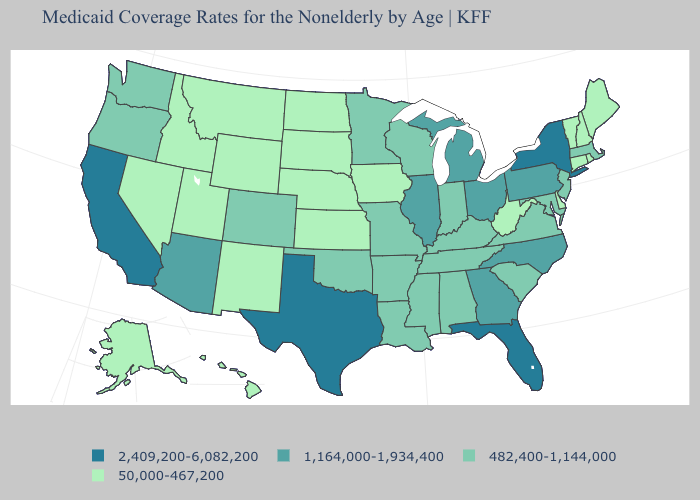Does the first symbol in the legend represent the smallest category?
Short answer required. No. Name the states that have a value in the range 2,409,200-6,082,200?
Quick response, please. California, Florida, New York, Texas. What is the highest value in the MidWest ?
Concise answer only. 1,164,000-1,934,400. Which states have the highest value in the USA?
Write a very short answer. California, Florida, New York, Texas. Which states hav the highest value in the West?
Be succinct. California. Which states have the lowest value in the MidWest?
Answer briefly. Iowa, Kansas, Nebraska, North Dakota, South Dakota. How many symbols are there in the legend?
Be succinct. 4. Name the states that have a value in the range 1,164,000-1,934,400?
Quick response, please. Arizona, Georgia, Illinois, Michigan, North Carolina, Ohio, Pennsylvania. Does Indiana have the highest value in the MidWest?
Quick response, please. No. Does New York have the highest value in the Northeast?
Give a very brief answer. Yes. What is the value of West Virginia?
Give a very brief answer. 50,000-467,200. Which states have the highest value in the USA?
Answer briefly. California, Florida, New York, Texas. What is the value of New York?
Quick response, please. 2,409,200-6,082,200. Name the states that have a value in the range 1,164,000-1,934,400?
Concise answer only. Arizona, Georgia, Illinois, Michigan, North Carolina, Ohio, Pennsylvania. Name the states that have a value in the range 50,000-467,200?
Quick response, please. Alaska, Connecticut, Delaware, Hawaii, Idaho, Iowa, Kansas, Maine, Montana, Nebraska, Nevada, New Hampshire, New Mexico, North Dakota, Rhode Island, South Dakota, Utah, Vermont, West Virginia, Wyoming. 